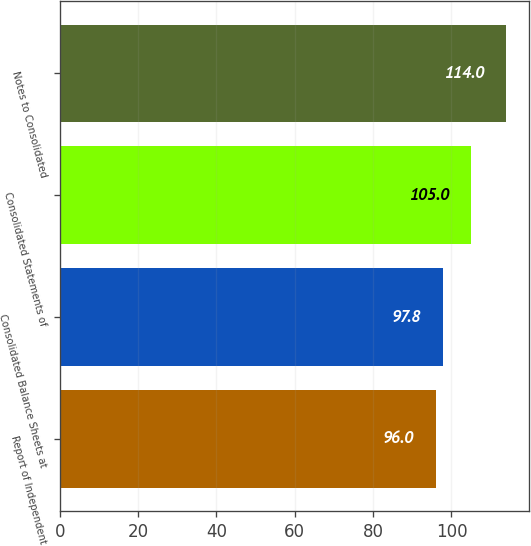Convert chart. <chart><loc_0><loc_0><loc_500><loc_500><bar_chart><fcel>Report of Independent<fcel>Consolidated Balance Sheets at<fcel>Consolidated Statements of<fcel>Notes to Consolidated<nl><fcel>96<fcel>97.8<fcel>105<fcel>114<nl></chart> 